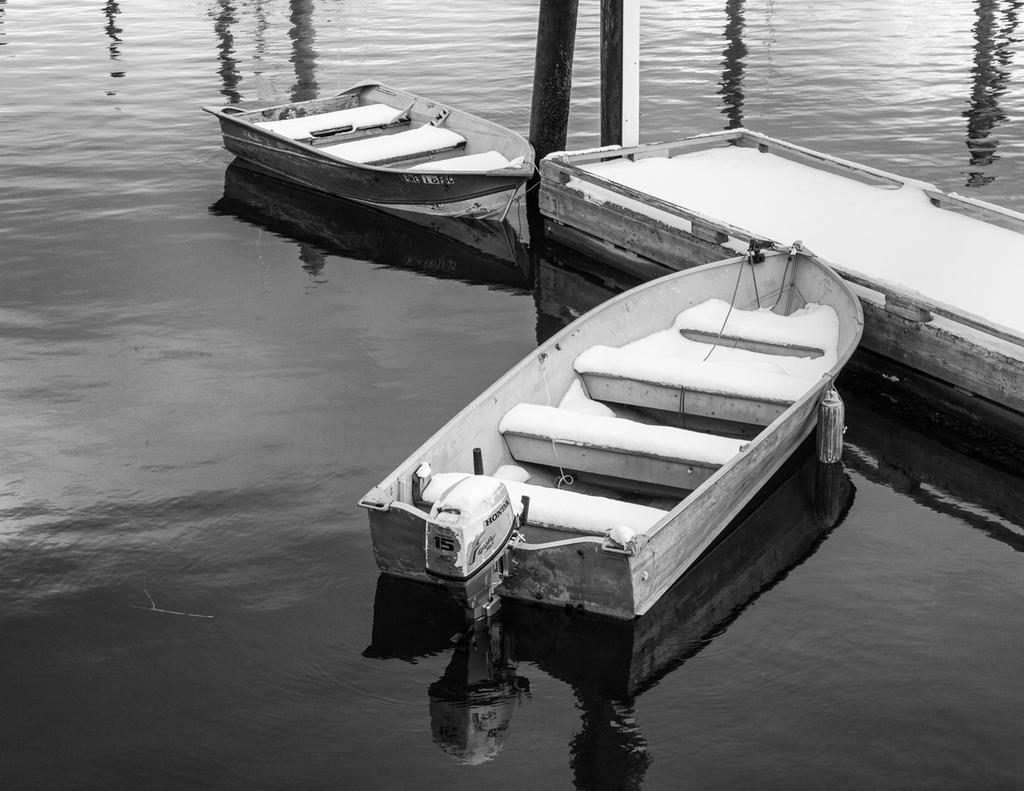What is the color scheme of the image? The image is black and white. What can be seen in the water in the image? There are boats in the water. What is located on the right side of the image? There is a walkway on the right side of the image. What type of wax is being used to create the boats in the image? There is no wax present in the image; the boats are actual boats in the water. What is the level of interest in the science of boat building in the image? The image does not provide any information about the level of interest in the science of boat building. 